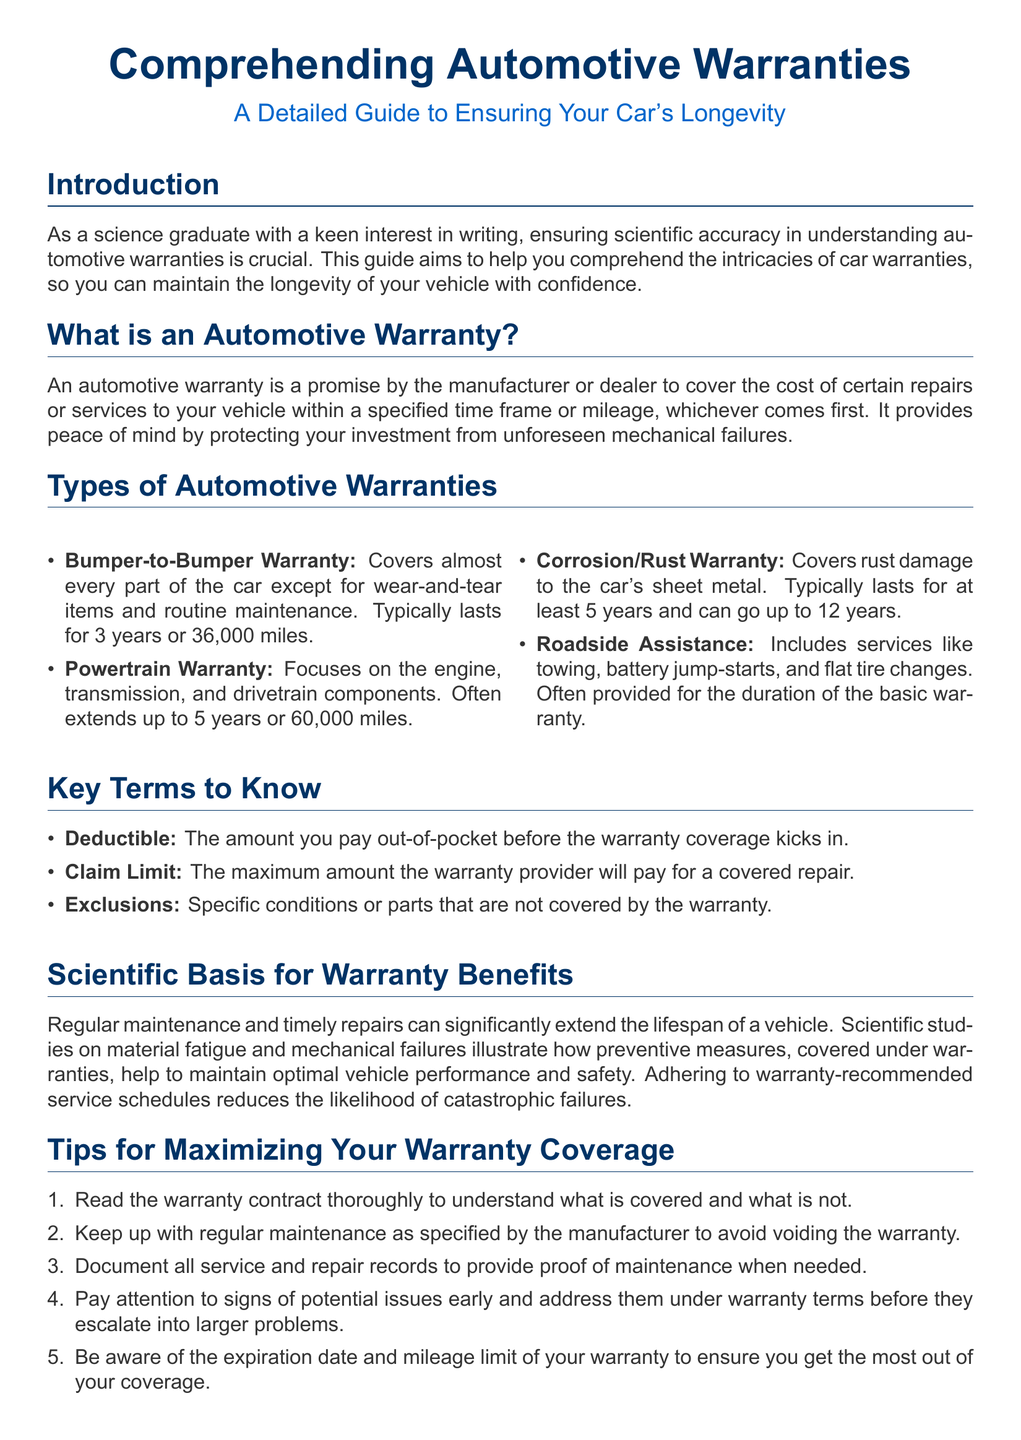What is the main purpose of this guide? The guide aims to help you comprehend the intricacies of car warranties, so you can maintain the longevity of your vehicle with confidence.
Answer: Maintain vehicle longevity What is a Bumper-to-Bumper Warranty? A Bumper-to-Bumper Warranty covers almost every part of the car except for wear-and-tear items and routine maintenance.
Answer: Covers almost every part How long does a Corrosion/Rust Warranty typically last? A Corrosion/Rust Warranty typically lasts for at least 5 years and can go up to 12 years.
Answer: 5 to 12 years What is a deductible? A deductible is the amount you pay out-of-pocket before the warranty coverage kicks in.
Answer: Amount paid out-of-pocket What should you do to avoid voiding your warranty? You should keep up with regular maintenance as specified by the manufacturer to avoid voiding the warranty.
Answer: Regular maintenance What is the focus of a Powertrain Warranty? A Powertrain Warranty focuses on the engine, transmission, and drivetrain components.
Answer: Engine, transmission, drivetrain What is one way to maximize your warranty coverage? One way to maximize your warranty coverage is to document all service and repair records to provide proof of maintenance when needed.
Answer: Document service records How many years does a typical Bumper-to-Bumper Warranty last? A typical Bumper-to-Bumper Warranty lasts for 3 years or 36,000 miles.
Answer: 3 years or 36,000 miles What is the role of scientific studies in the context of warranties? Scientific studies support the idea that regular maintenance and timely repairs can significantly extend the lifespan of a vehicle.
Answer: Extend vehicle lifespan 